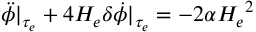Convert formula to latex. <formula><loc_0><loc_0><loc_500><loc_500>\ddot { \phi } | _ { \tau _ { e } } + 4 H _ { e } \delta \dot { \phi } | _ { \tau _ { e } } = - 2 \alpha { H _ { e } } ^ { 2 }</formula> 